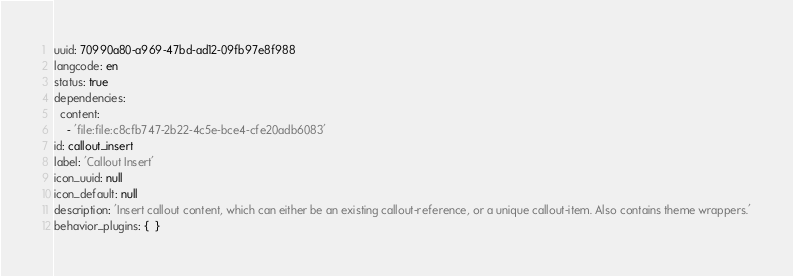Convert code to text. <code><loc_0><loc_0><loc_500><loc_500><_YAML_>uuid: 70990a80-a969-47bd-ad12-09fb97e8f988
langcode: en
status: true
dependencies:
  content:
    - 'file:file:c8cfb747-2b22-4c5e-bce4-cfe20adb6083'
id: callout_insert
label: 'Callout Insert'
icon_uuid: null
icon_default: null
description: 'Insert callout content, which can either be an existing callout-reference, or a unique callout-item. Also contains theme wrappers.'
behavior_plugins: {  }
</code> 